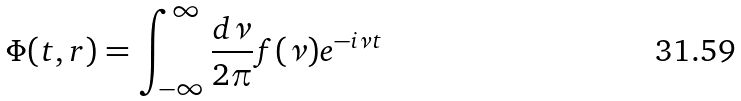Convert formula to latex. <formula><loc_0><loc_0><loc_500><loc_500>\Phi ( t , r ) = \int _ { - \infty } ^ { \infty } \frac { d \nu } { 2 \pi } f ( \nu ) e ^ { - i \nu t }</formula> 